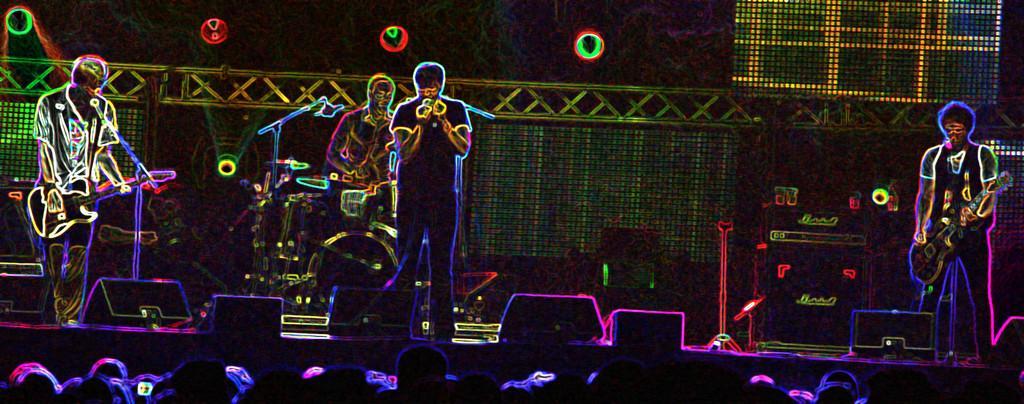Describe this image in one or two sentences. In this image we can see a four persons in the foreground and among them three persons are playing musical instruments. The person in the middle is holding a mic. At the bottom we can see group of persons and objects. There are few mics with stands in the foreground. In the background, we can see few objects. At the top we have few lights. 